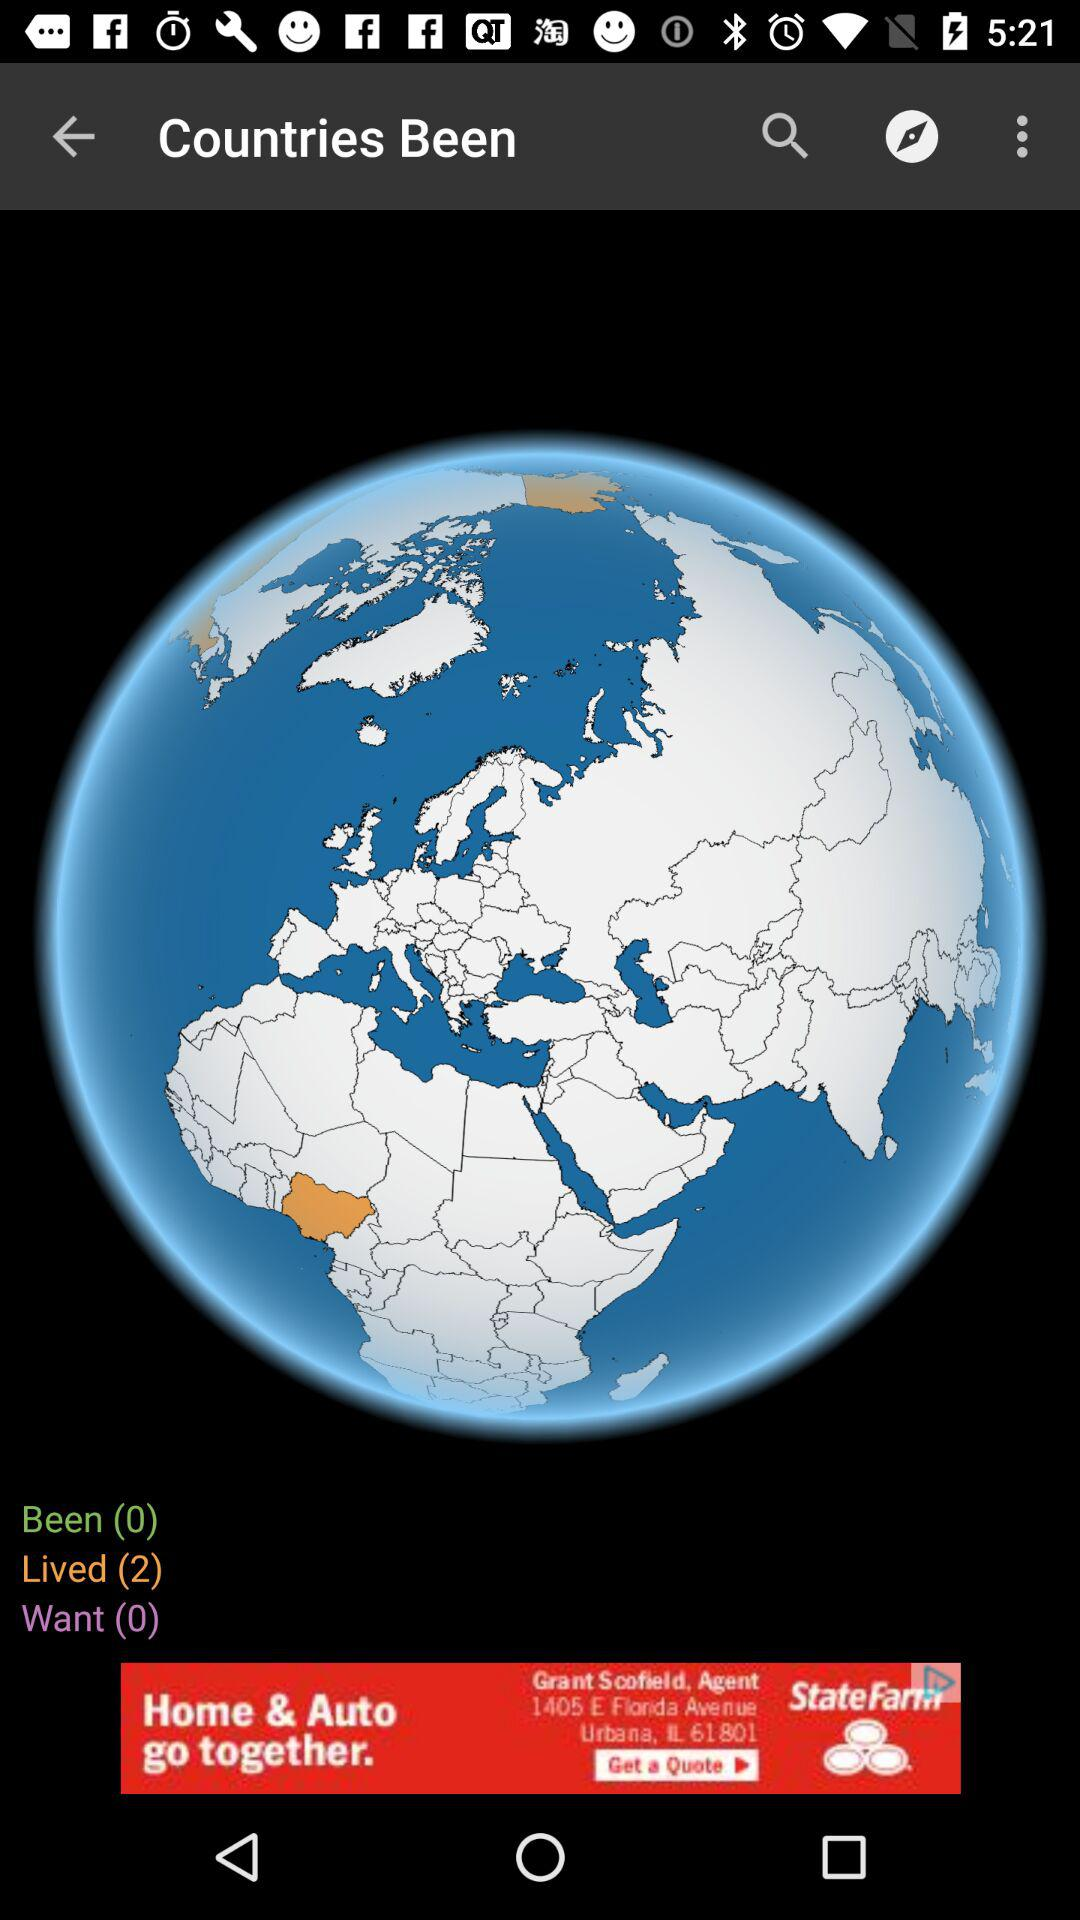How many countries have I been to and lived in?
Answer the question using a single word or phrase. 2 